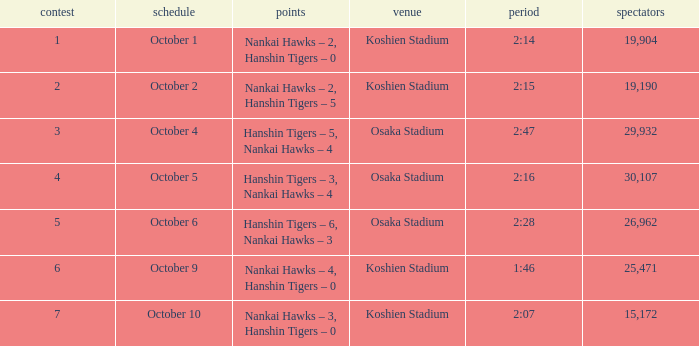Which Score has a Time of 2:28? Hanshin Tigers – 6, Nankai Hawks – 3. Write the full table. {'header': ['contest', 'schedule', 'points', 'venue', 'period', 'spectators'], 'rows': [['1', 'October 1', 'Nankai Hawks – 2, Hanshin Tigers – 0', 'Koshien Stadium', '2:14', '19,904'], ['2', 'October 2', 'Nankai Hawks – 2, Hanshin Tigers – 5', 'Koshien Stadium', '2:15', '19,190'], ['3', 'October 4', 'Hanshin Tigers – 5, Nankai Hawks – 4', 'Osaka Stadium', '2:47', '29,932'], ['4', 'October 5', 'Hanshin Tigers – 3, Nankai Hawks – 4', 'Osaka Stadium', '2:16', '30,107'], ['5', 'October 6', 'Hanshin Tigers – 6, Nankai Hawks – 3', 'Osaka Stadium', '2:28', '26,962'], ['6', 'October 9', 'Nankai Hawks – 4, Hanshin Tigers – 0', 'Koshien Stadium', '1:46', '25,471'], ['7', 'October 10', 'Nankai Hawks – 3, Hanshin Tigers – 0', 'Koshien Stadium', '2:07', '15,172']]} 